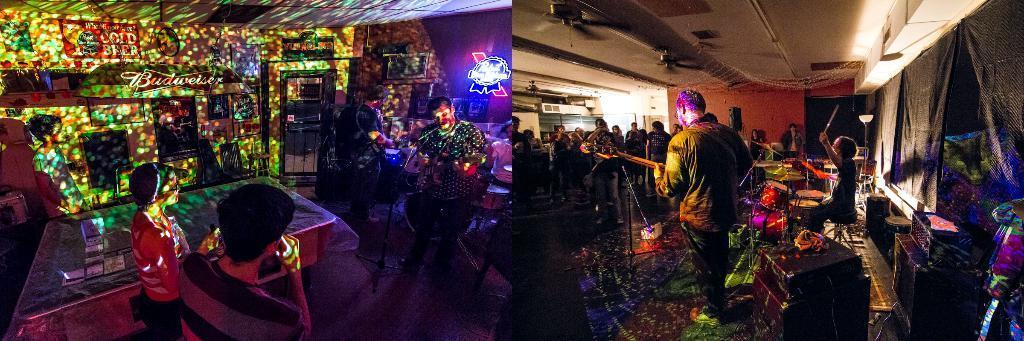In one or two sentences, can you explain what this image depicts? This picture shows the inner view of a building. So many different objects attached to the ceiling, some text on the wall, the wall is decorated with so many objects and posters. There are so many people standing and holding some objects. Some people are playing musical instruments and one person is sitting in a chair. There is one table covered with cloth, one stool, some objects are on the table and one door with one small board attached to it. So many different kinds of objects are on the surface. 